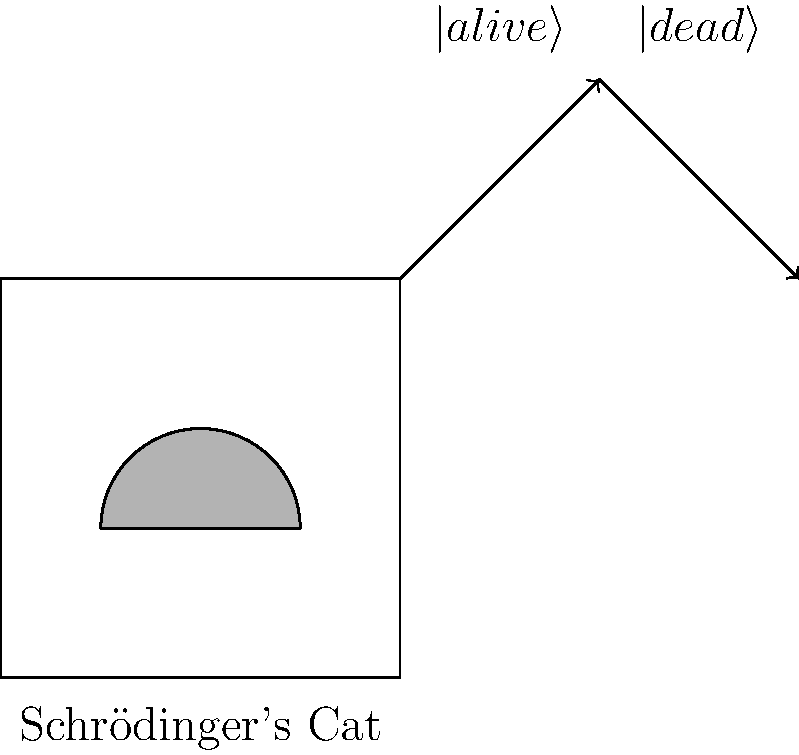In a twist on the classic thought experiment, Schrödinger's cat finds itself in a state of quantum entanglement with its box. If we observe the box to be in a superposition of "open" and "closed" states, what witty observation can we make about the cat's predicament? Let's break this down step-by-step:

1) In the original Schrödinger's cat thought experiment, the cat is in a superposition of alive and dead states until observed.

2) In this twisted version, we've entangled the cat with the box itself.

3) Quantum entanglement means that the states of two particles are correlated, even at a distance.

4) If the box is in a superposition of open and closed states, it can be represented as:
   $$|\text{box}\rangle = \frac{1}{\sqrt{2}}(|\text{open}\rangle + |\text{closed}\rangle)$$

5) Due to the entanglement, the cat's state is correlated with the box's state:
   $$|\text{system}\rangle = \frac{1}{\sqrt{2}}(|\text{open}\rangle|\text{escaped}\rangle + |\text{closed}\rangle|\text{trapped}\rangle)$$

6) This means the cat is simultaneously "escaped" and "trapped" until we observe the box.

7) The humor lies in the fact that the cat's freedom is now as uncertain as its life was in the original experiment.

Therefore, we can wittily observe that the cat is now both "out of the box" and "in the box" until we look, adding a new layer of existential uncertainty to its already precarious situation.
Answer: The cat is simultaneously "out of the box" and "in the box" until observed, doubling its existential crisis. 